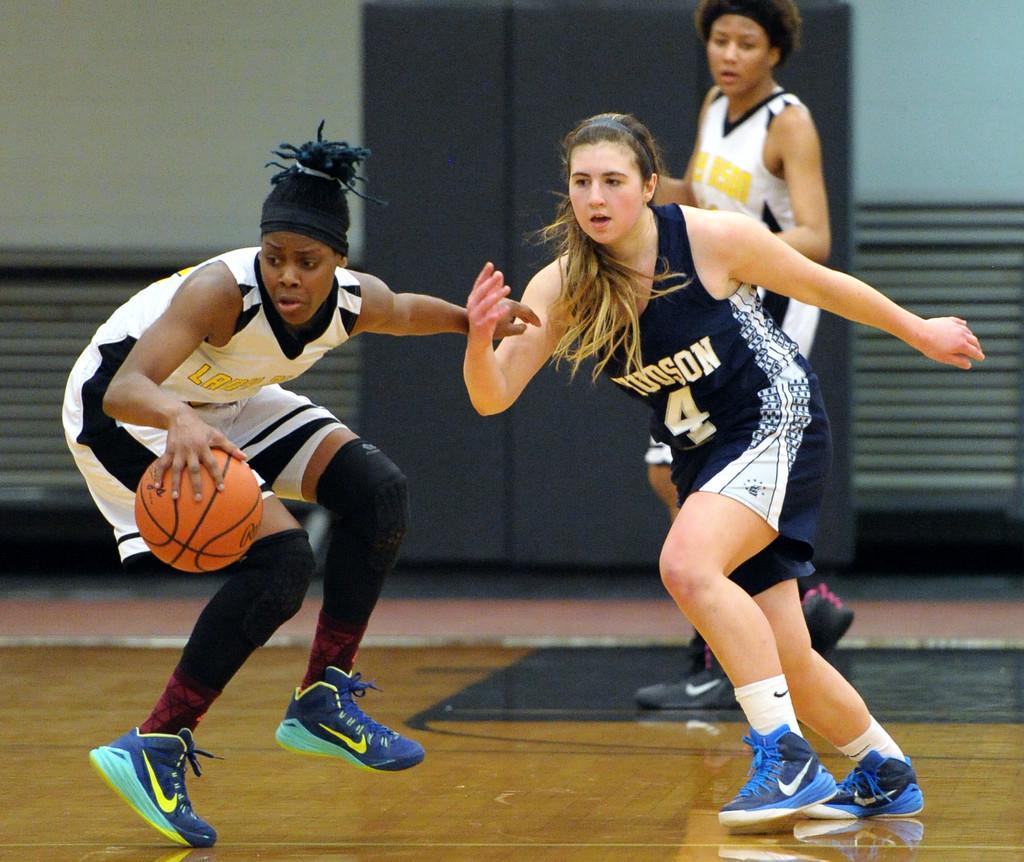In one or two sentences, can you explain what this image depicts? In the image I can see women among them the woman on the left side is holding a ball in the hand. In the background I can see a wall and some other objects on the floor. These people are wearing shoes, tank tops and shorts. 